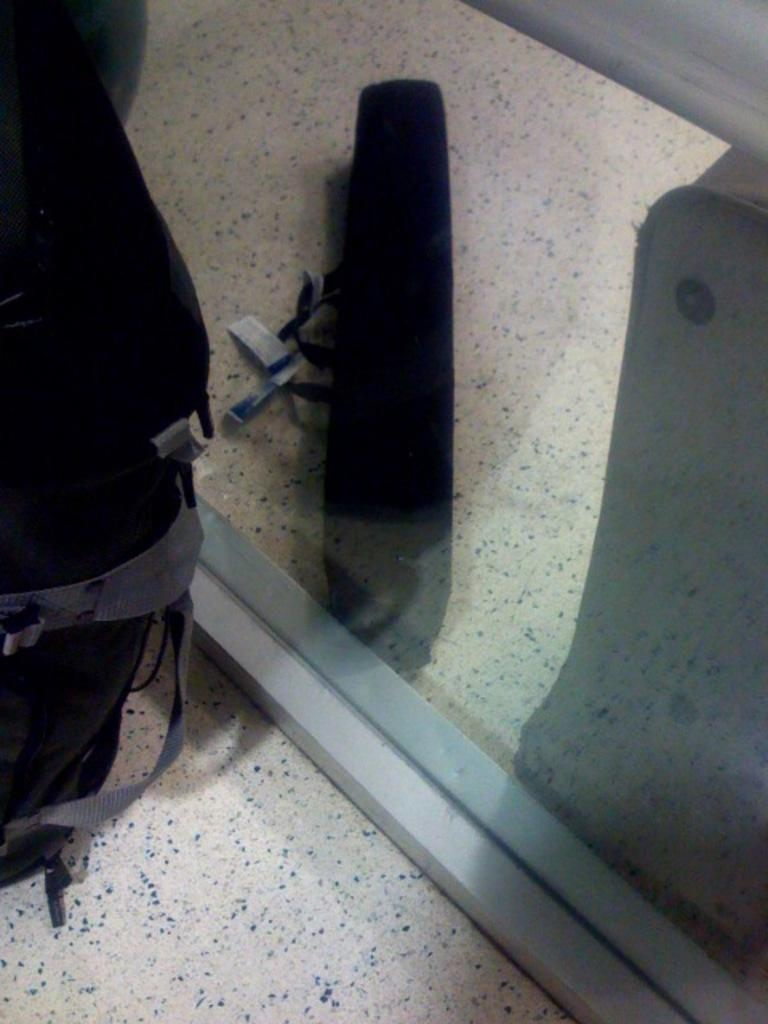What is on the floor in the image? There is a bag on the floor in the image. What else can be seen in the image besides the bag? There is a glass in the image. What is visible through the glass? An object is visible through the glass. What type of grape is being used to start the event in the image? There is no grape or event present in the image. 